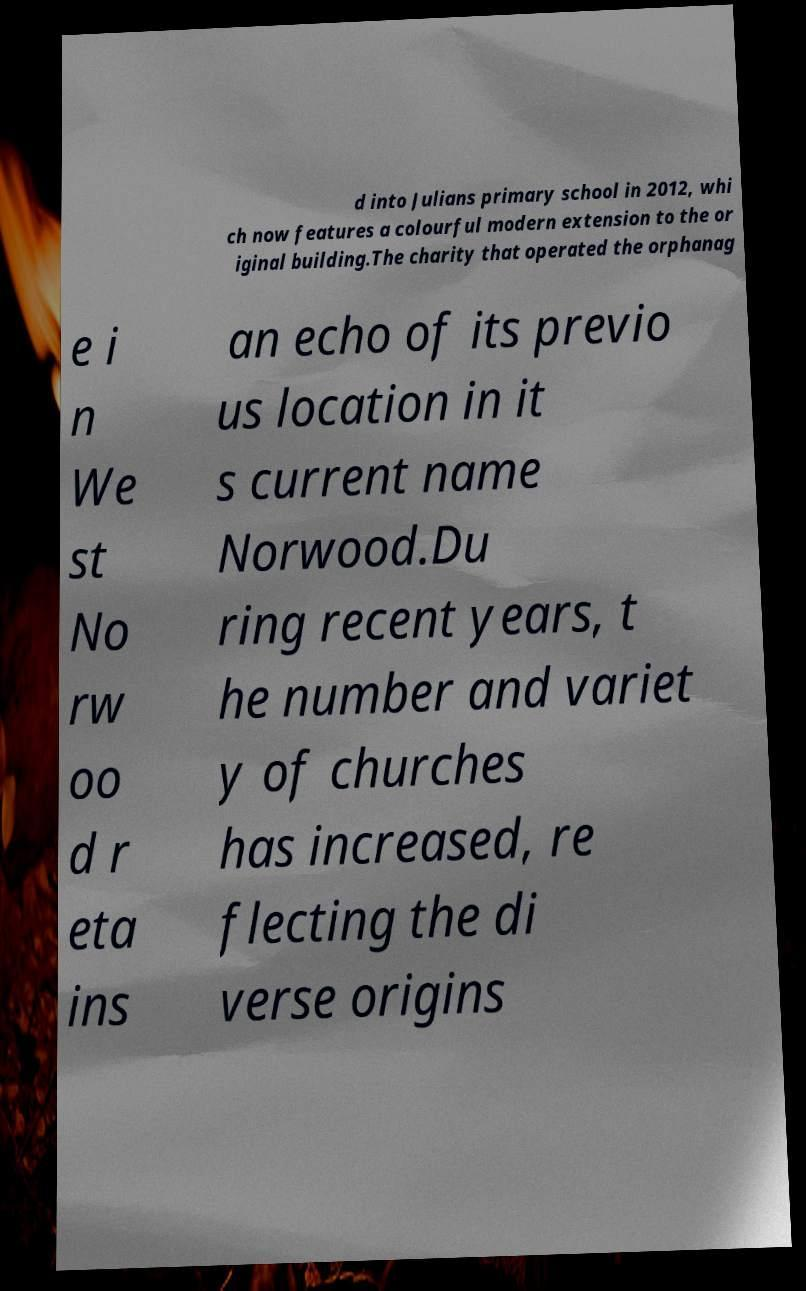Please read and relay the text visible in this image. What does it say? d into Julians primary school in 2012, whi ch now features a colourful modern extension to the or iginal building.The charity that operated the orphanag e i n We st No rw oo d r eta ins an echo of its previo us location in it s current name Norwood.Du ring recent years, t he number and variet y of churches has increased, re flecting the di verse origins 